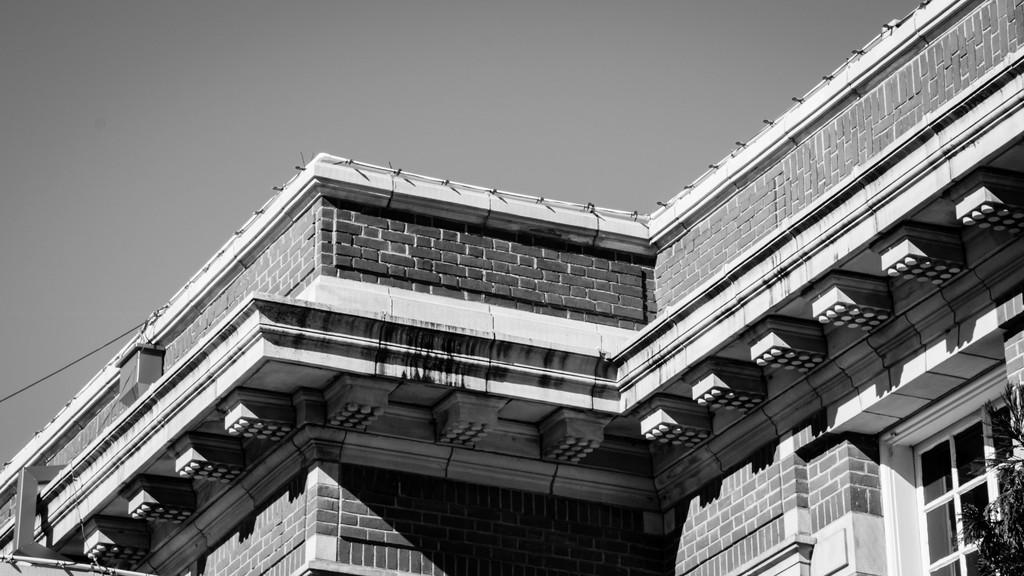What type of image is shown in the picture? The image contains a black and white picture of a building. What specific features can be observed on the building? The building has windows. What type of vegetation is visible in the image? Leaves are visible in the image. What else can be seen in the image besides the building? There is an electric wire in the image. What is visible in the background of the image? The sky is visible in the image. What type of alarm can be heard going off in the image? There is no alarm present in the image, and therefore no sound can be heard. Can you tell me how many pickles are on the table in the image? There is no table or pickles present in the image. 